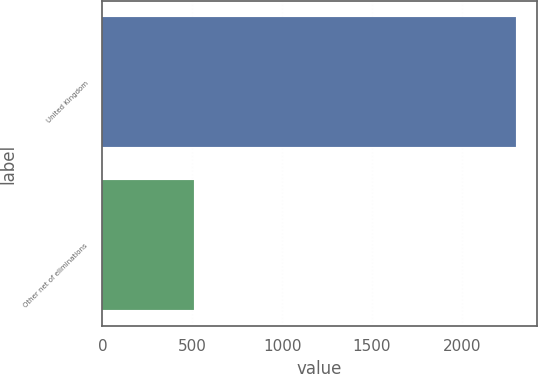<chart> <loc_0><loc_0><loc_500><loc_500><bar_chart><fcel>United Kingdom<fcel>Other net of eliminations<nl><fcel>2300<fcel>510<nl></chart> 